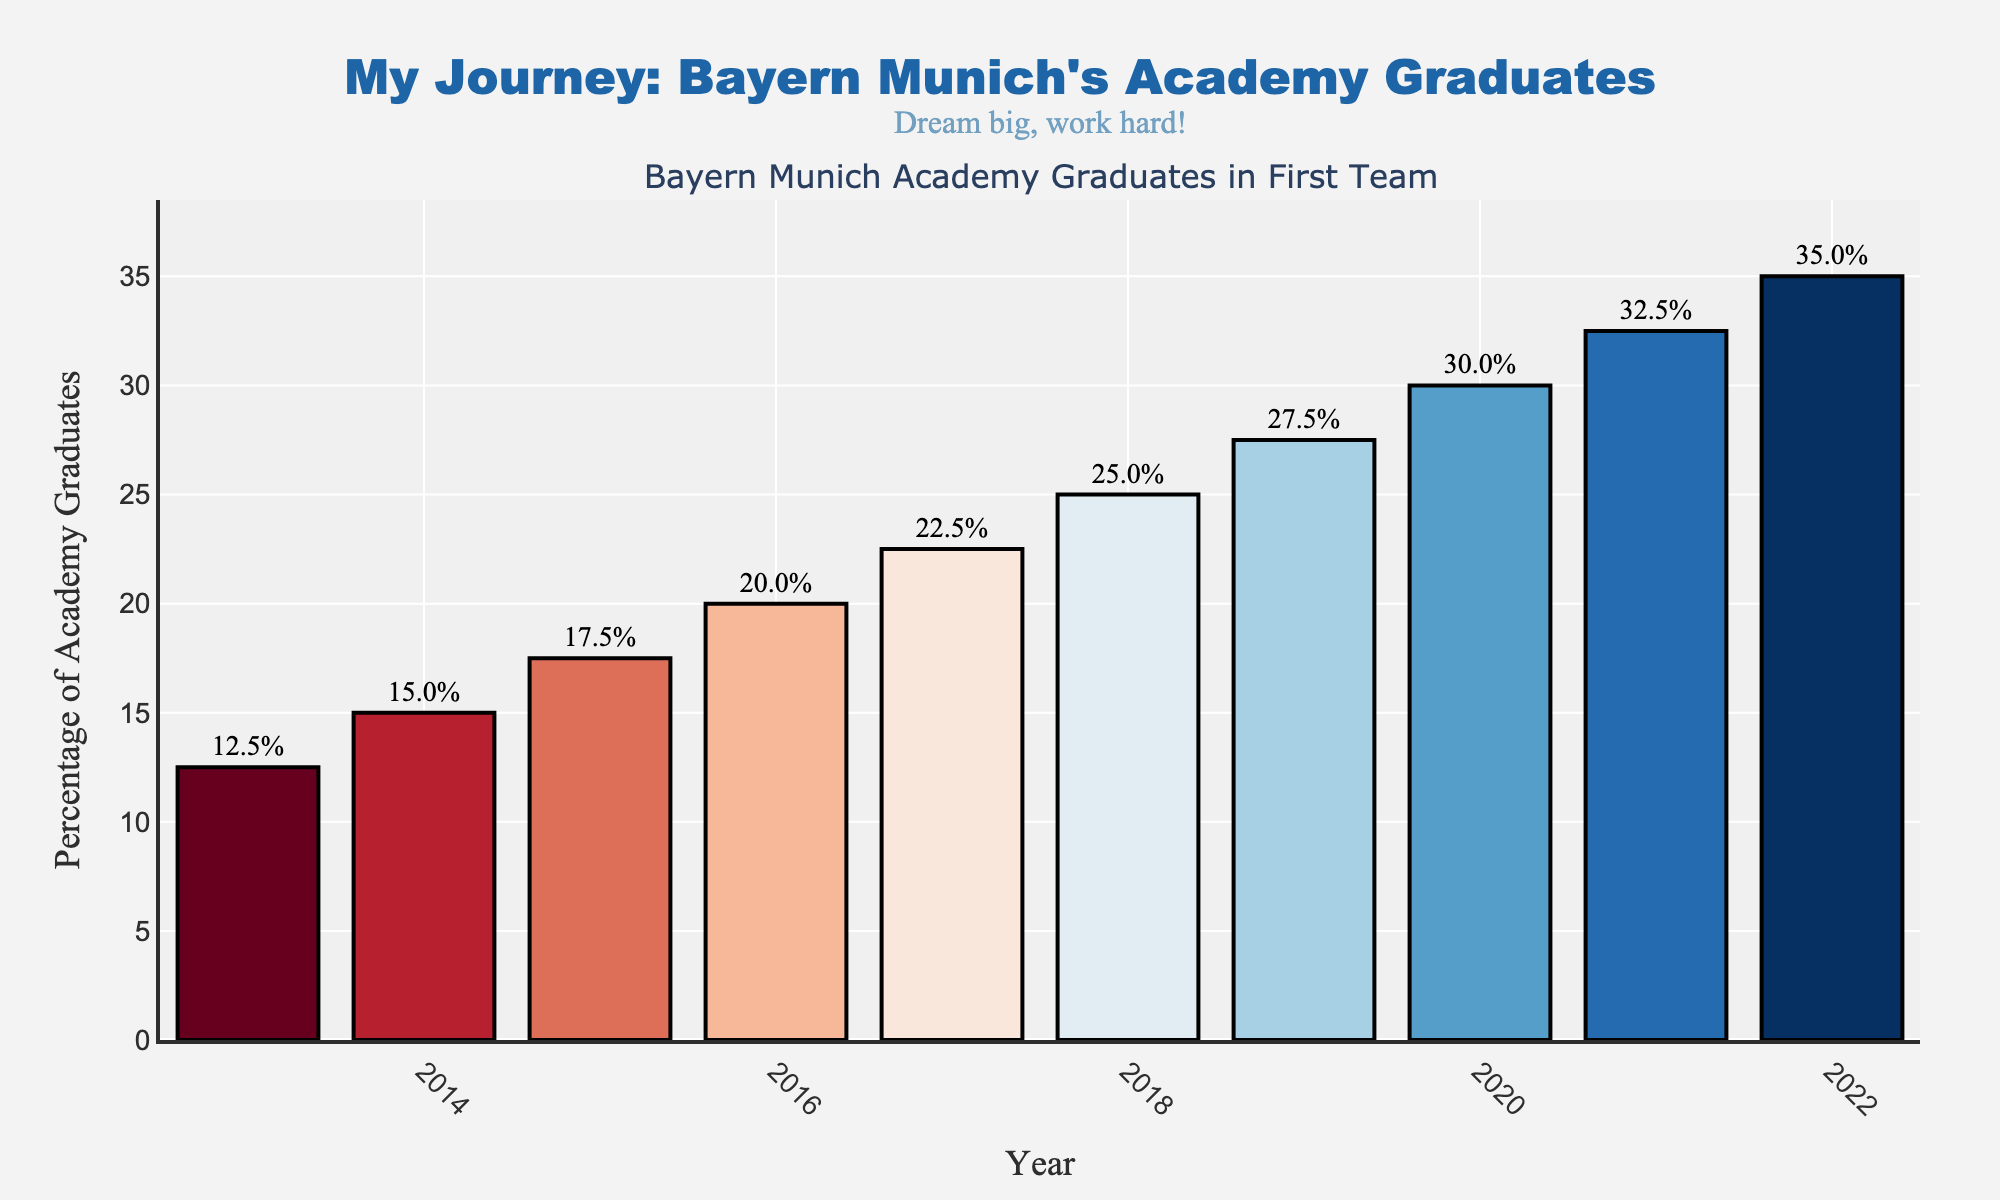what is the highest percentage of Bayern Munich academy graduates in the first team squad over the last 10 years? By examining the bar heights and the annotations, the highest percentage is seen at the year 2022, which is 35%.
Answer: 35% what is the lowest percentage of Bayern Munich academy graduates in the first team squad over the last 10 years? By looking at the smallest bar towards the year 2013, we can see that the lowest percentage is 12.5%.
Answer: 12.5% how much has the percentage of academy graduates increased from 2013 to 2022? The percentage in 2013 is 12.5%, and in 2022, it’s 35.0%. We find the difference: 35.0% - 12.5% = 22.5%.
Answer: 22.5% what is the average percentage of academy graduates over the last 10 years? Sum all yearly percentages: 12.5 + 15.0 + 17.5 + 20.0 + 22.5 + 25.0 + 27.5 + 30.0 + 32.5 + 35.0 = 237.5. Divide by 10 (the number of years): 237.5 / 10 = 23.75%.
Answer: 23.75% by how much did the percentage of academy graduates increase from 2017 to 2020? The percentage in 2017 is 22.5%, and in 2020, it is 30.0%. Hence, the increase is 30.0% - 22.5% = 7.5%.
Answer: 7.5% which year had the highest growth in the percentage of academy graduates compared to its previous year? We compare the differences year-over-year. The highest difference is between 2015 (17.5%) and 2016 (20.0%), which is 2.5%. This is the year with the highest growth.
Answer: 2016 what is the median percentage of academy graduates from 2013 to 2022? List the percentages in ascending order: 12.5, 15.0, 17.5, 20.0, 22.5, 25.0, 27.5, 30.0, 32.5, 35.0. The median (middle value) is the average of the 5th and 6th values: (22.5 + 25.0) / 2 = 23.75%.
Answer: 23.75% compare the percentage increase between the intervals of 2013-2017 and 2018-2022. Which interval had a higher increase? For 2013-2017, percentage in 2017 (22.5%) - percentage in 2013 (12.5%) = 10%. For 2018-2022, percentage in 2022 (35.0%) - percentage in 2018 (25.0%) = 10%. Both intervals had the same increase.
Answer: Both are equal what visual pattern can you observe in the color of the bars from 2013 to 2022? Observing the bar colors, we note a gradient changing from cooler (red tones) to warmer (blue tones) as we move from 2013 to 2022.
Answer: Gradient from red to blue 